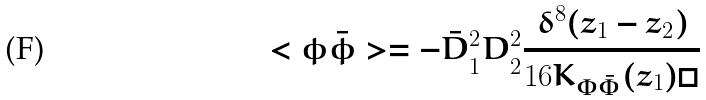Convert formula to latex. <formula><loc_0><loc_0><loc_500><loc_500>< \phi \bar { \phi } > = - \bar { D } ^ { 2 } _ { 1 } D ^ { 2 } _ { 2 } \frac { \delta ^ { 8 } ( z _ { 1 } - z _ { 2 } ) } { 1 6 K _ { \Phi \bar { \Phi } } ( z _ { 1 } ) \Box }</formula> 